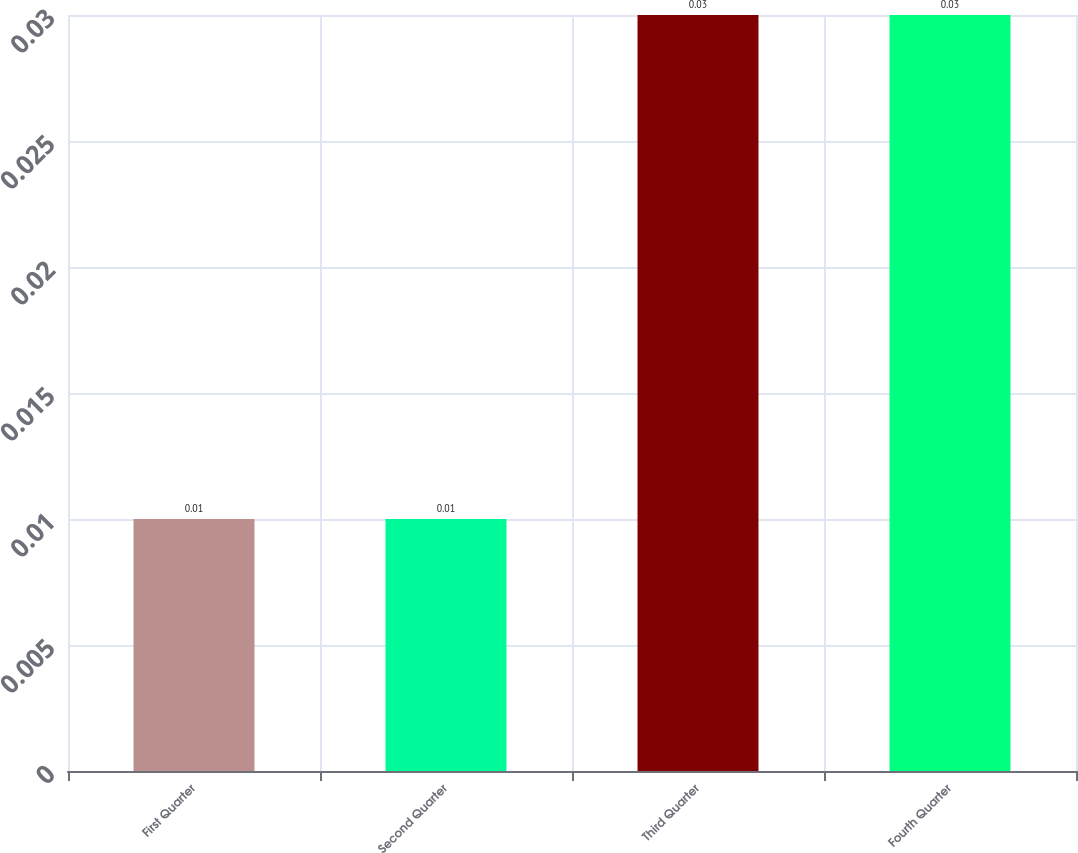Convert chart to OTSL. <chart><loc_0><loc_0><loc_500><loc_500><bar_chart><fcel>First Quarter<fcel>Second Quarter<fcel>Third Quarter<fcel>Fourth Quarter<nl><fcel>0.01<fcel>0.01<fcel>0.03<fcel>0.03<nl></chart> 